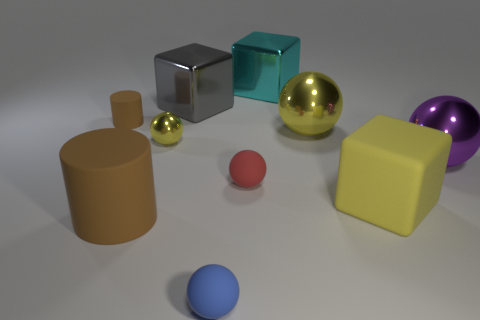Subtract all cylinders. How many objects are left? 8 Add 1 brown rubber cylinders. How many brown rubber cylinders are left? 3 Add 7 red shiny spheres. How many red shiny spheres exist? 7 Subtract all yellow cubes. How many cubes are left? 2 Subtract all yellow blocks. How many blocks are left? 2 Subtract 1 cyan blocks. How many objects are left? 9 Subtract 2 cylinders. How many cylinders are left? 0 Subtract all green blocks. Subtract all green cylinders. How many blocks are left? 3 Subtract all red cylinders. How many yellow balls are left? 2 Subtract all small cyan matte blocks. Subtract all big yellow blocks. How many objects are left? 9 